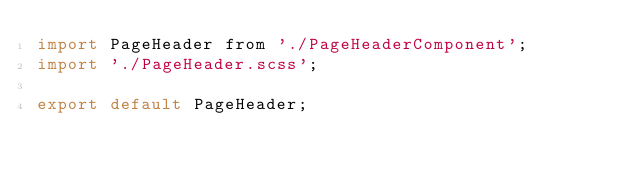Convert code to text. <code><loc_0><loc_0><loc_500><loc_500><_JavaScript_>import PageHeader from './PageHeaderComponent';
import './PageHeader.scss';

export default PageHeader;
</code> 